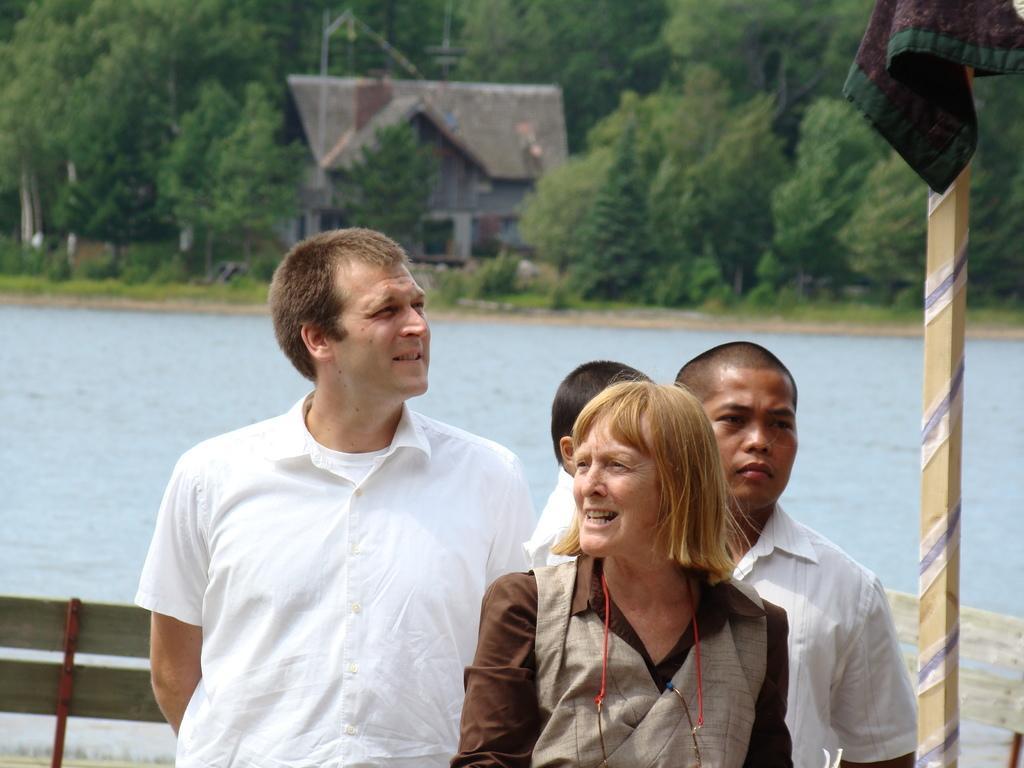In one or two sentences, can you explain what this image depicts? In this image we can see many trees and plants. There are few people in the image. There is a lake in the image. There are few benches in the image. There is an object at the right side of the image. There is a house in the image. 